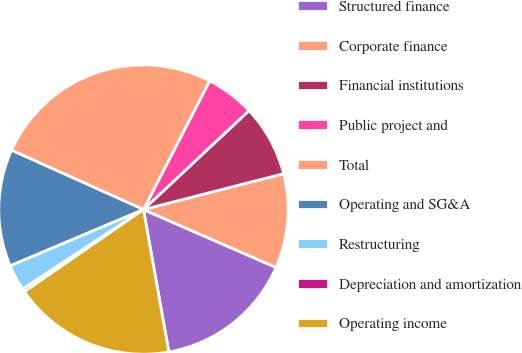<chart> <loc_0><loc_0><loc_500><loc_500><pie_chart><fcel>Structured finance<fcel>Corporate finance<fcel>Financial institutions<fcel>Public project and<fcel>Total<fcel>Operating and SG&A<fcel>Restructuring<fcel>Depreciation and amortization<fcel>Operating income<nl><fcel>15.64%<fcel>10.54%<fcel>8.0%<fcel>5.45%<fcel>25.84%<fcel>13.09%<fcel>2.9%<fcel>0.35%<fcel>18.19%<nl></chart> 